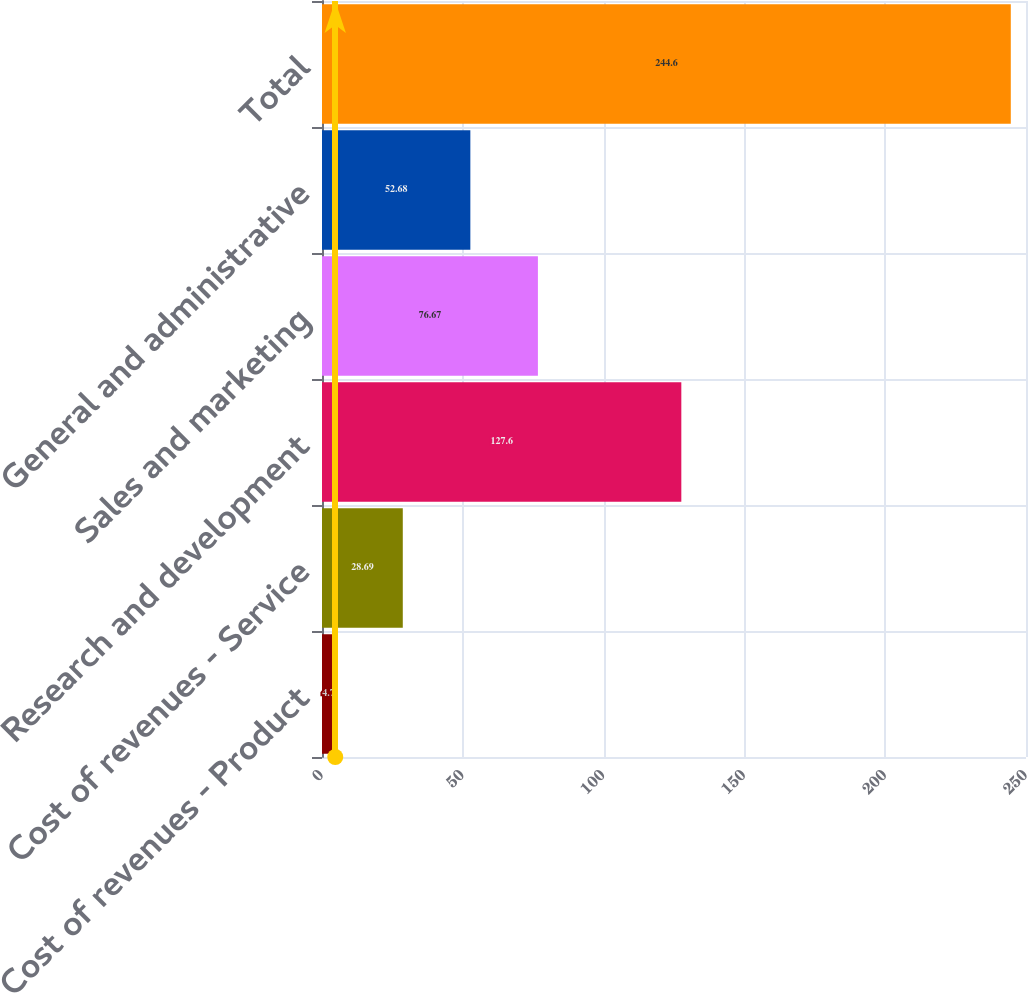<chart> <loc_0><loc_0><loc_500><loc_500><bar_chart><fcel>Cost of revenues - Product<fcel>Cost of revenues - Service<fcel>Research and development<fcel>Sales and marketing<fcel>General and administrative<fcel>Total<nl><fcel>4.7<fcel>28.69<fcel>127.6<fcel>76.67<fcel>52.68<fcel>244.6<nl></chart> 